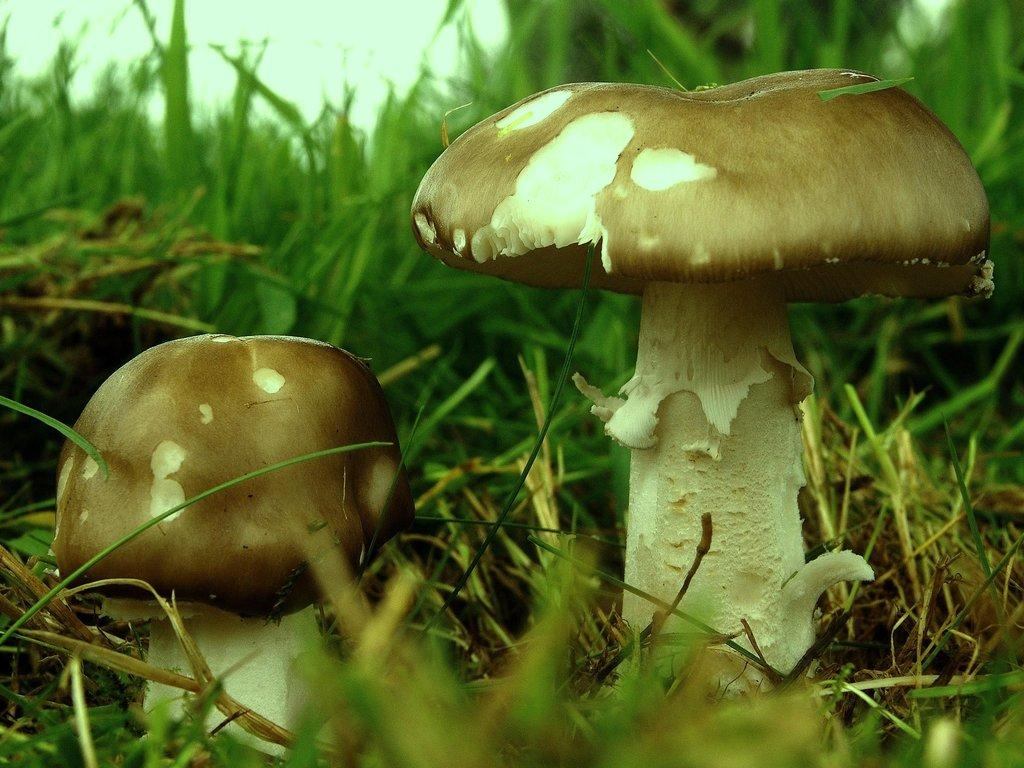What are the main subjects in the middle of the image? There are two mushrooms in the middle of the image. What type of vegetation can be seen in the background of the image? There is grass in the background of the image. How many fictional characters are present in the image? There are no fictional characters present in the image; it features two mushrooms and grass. 